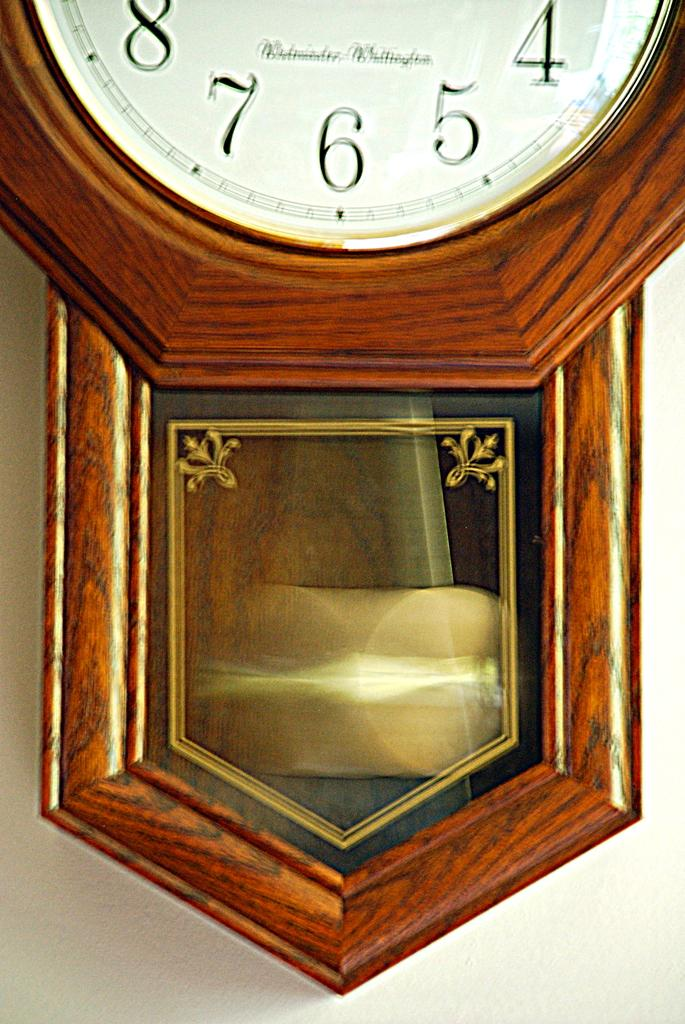Provide a one-sentence caption for the provided image. A close up of a clock that shows the numbers 4, 5, 6, 7, and 8. 